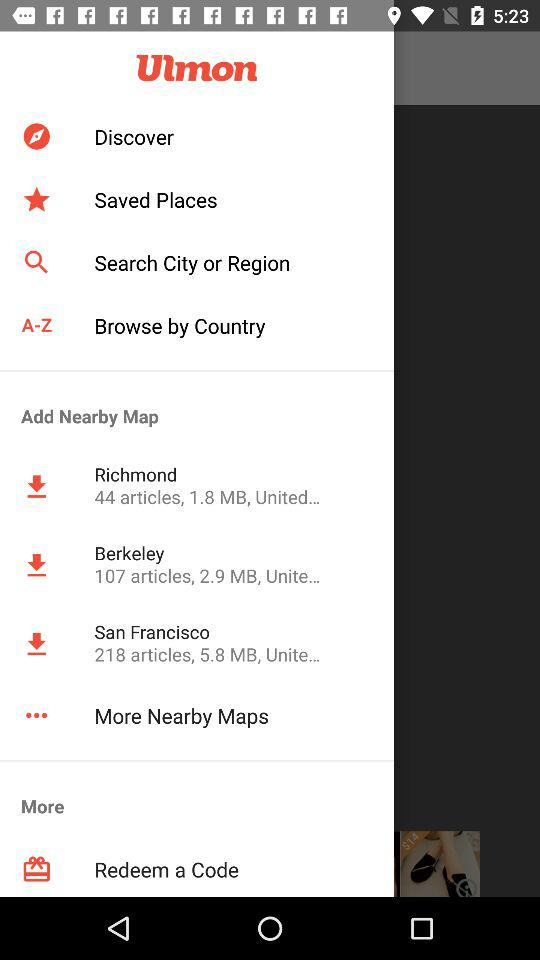How many notifications are there in "Discover"?
When the provided information is insufficient, respond with <no answer>. <no answer> 